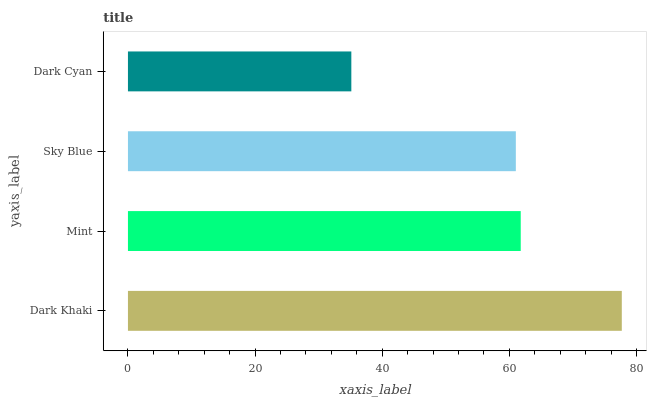Is Dark Cyan the minimum?
Answer yes or no. Yes. Is Dark Khaki the maximum?
Answer yes or no. Yes. Is Mint the minimum?
Answer yes or no. No. Is Mint the maximum?
Answer yes or no. No. Is Dark Khaki greater than Mint?
Answer yes or no. Yes. Is Mint less than Dark Khaki?
Answer yes or no. Yes. Is Mint greater than Dark Khaki?
Answer yes or no. No. Is Dark Khaki less than Mint?
Answer yes or no. No. Is Mint the high median?
Answer yes or no. Yes. Is Sky Blue the low median?
Answer yes or no. Yes. Is Dark Khaki the high median?
Answer yes or no. No. Is Dark Khaki the low median?
Answer yes or no. No. 